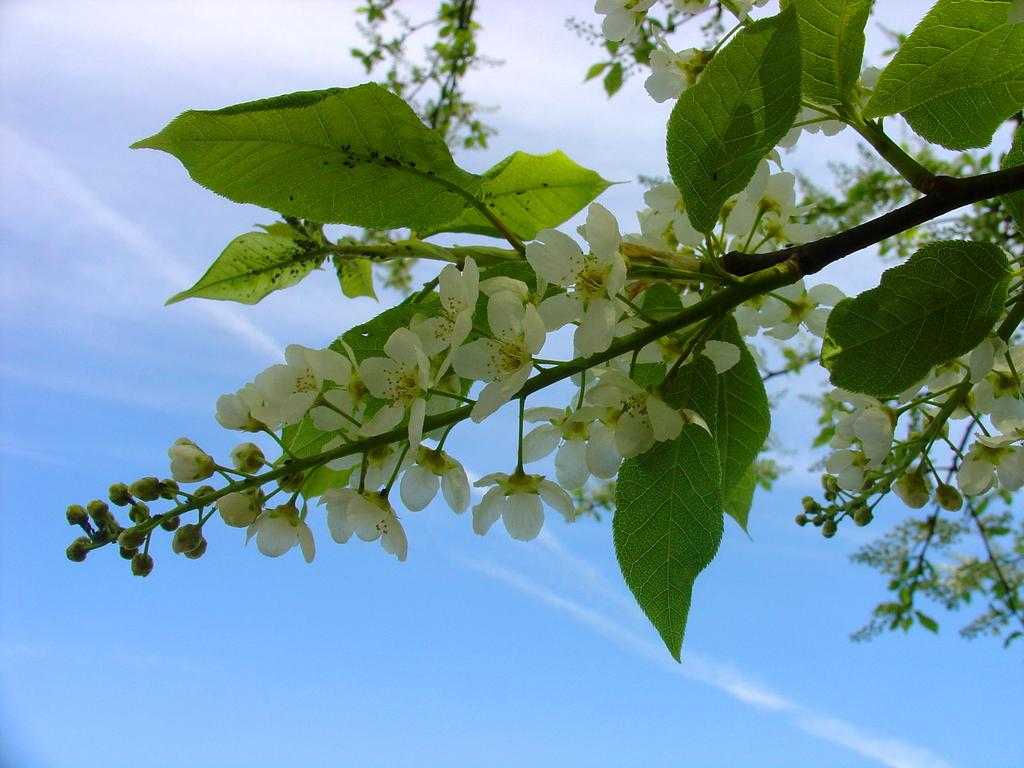What can be seen in the background of the image? The sky is visible in the background of the image. What type of vegetation is present in the image? Green leaves and white flowers are visible in the image. Are there any unopened flowers in the image? Yes, buds are present in the image. What supports the flowers and leaves in the image? Stems are visible in the image. What type of loaf is being baked in the image? There is no loaf or baking activity present in the image; it features vegetation with green leaves, white flowers, buds, and stems. 